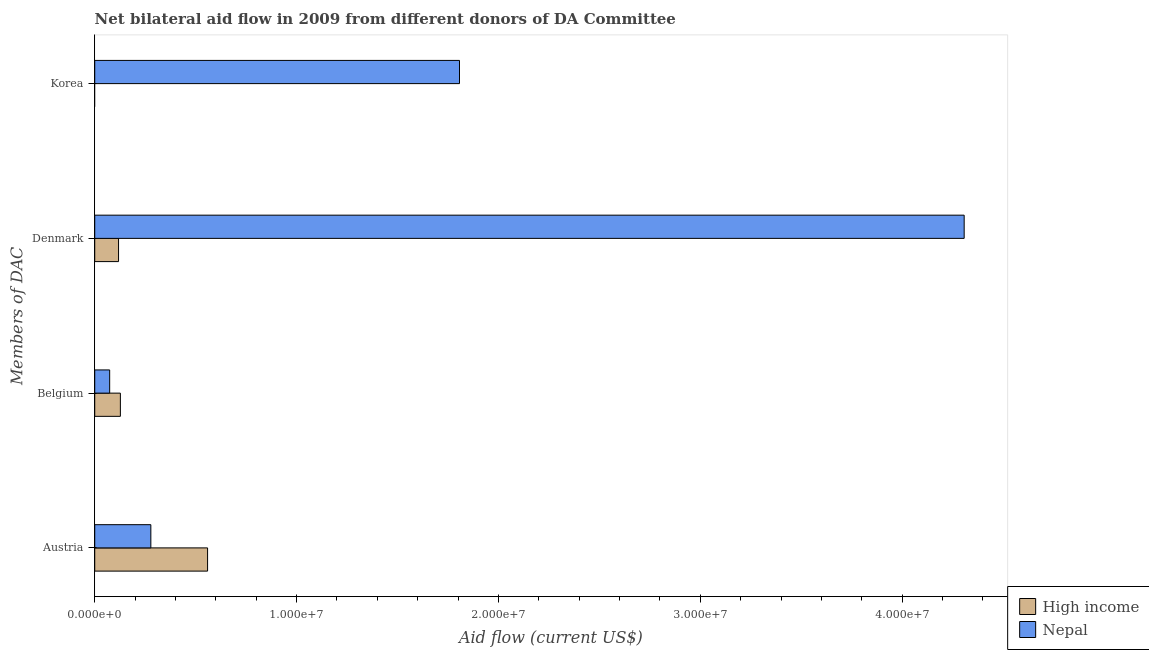Are the number of bars on each tick of the Y-axis equal?
Provide a succinct answer. No. How many bars are there on the 3rd tick from the top?
Make the answer very short. 2. How many bars are there on the 3rd tick from the bottom?
Provide a short and direct response. 2. What is the label of the 2nd group of bars from the top?
Ensure brevity in your answer.  Denmark. What is the amount of aid given by korea in Nepal?
Offer a very short reply. 1.81e+07. Across all countries, what is the maximum amount of aid given by denmark?
Offer a very short reply. 4.31e+07. Across all countries, what is the minimum amount of aid given by belgium?
Ensure brevity in your answer.  7.40e+05. In which country was the amount of aid given by austria maximum?
Your answer should be very brief. High income. What is the total amount of aid given by korea in the graph?
Provide a short and direct response. 1.81e+07. What is the difference between the amount of aid given by belgium in High income and that in Nepal?
Your answer should be very brief. 5.30e+05. What is the difference between the amount of aid given by belgium in Nepal and the amount of aid given by korea in High income?
Your answer should be compact. 7.40e+05. What is the average amount of aid given by denmark per country?
Provide a succinct answer. 2.21e+07. What is the difference between the amount of aid given by belgium and amount of aid given by korea in Nepal?
Offer a very short reply. -1.73e+07. What is the ratio of the amount of aid given by denmark in High income to that in Nepal?
Your answer should be very brief. 0.03. Is the amount of aid given by austria in High income less than that in Nepal?
Keep it short and to the point. No. What is the difference between the highest and the second highest amount of aid given by denmark?
Keep it short and to the point. 4.19e+07. What is the difference between the highest and the lowest amount of aid given by denmark?
Keep it short and to the point. 4.19e+07. In how many countries, is the amount of aid given by denmark greater than the average amount of aid given by denmark taken over all countries?
Offer a very short reply. 1. Is the sum of the amount of aid given by austria in Nepal and High income greater than the maximum amount of aid given by korea across all countries?
Your answer should be very brief. No. Is it the case that in every country, the sum of the amount of aid given by denmark and amount of aid given by austria is greater than the sum of amount of aid given by korea and amount of aid given by belgium?
Make the answer very short. No. How many countries are there in the graph?
Offer a terse response. 2. What is the difference between two consecutive major ticks on the X-axis?
Your answer should be compact. 1.00e+07. Does the graph contain any zero values?
Provide a succinct answer. Yes. Where does the legend appear in the graph?
Your response must be concise. Bottom right. How many legend labels are there?
Provide a short and direct response. 2. What is the title of the graph?
Make the answer very short. Net bilateral aid flow in 2009 from different donors of DA Committee. What is the label or title of the X-axis?
Offer a terse response. Aid flow (current US$). What is the label or title of the Y-axis?
Your answer should be very brief. Members of DAC. What is the Aid flow (current US$) of High income in Austria?
Provide a succinct answer. 5.59e+06. What is the Aid flow (current US$) in Nepal in Austria?
Make the answer very short. 2.78e+06. What is the Aid flow (current US$) of High income in Belgium?
Offer a very short reply. 1.27e+06. What is the Aid flow (current US$) of Nepal in Belgium?
Keep it short and to the point. 7.40e+05. What is the Aid flow (current US$) in High income in Denmark?
Make the answer very short. 1.18e+06. What is the Aid flow (current US$) in Nepal in Denmark?
Your answer should be very brief. 4.31e+07. What is the Aid flow (current US$) of High income in Korea?
Ensure brevity in your answer.  0. What is the Aid flow (current US$) in Nepal in Korea?
Ensure brevity in your answer.  1.81e+07. Across all Members of DAC, what is the maximum Aid flow (current US$) of High income?
Your answer should be compact. 5.59e+06. Across all Members of DAC, what is the maximum Aid flow (current US$) in Nepal?
Provide a succinct answer. 4.31e+07. Across all Members of DAC, what is the minimum Aid flow (current US$) of Nepal?
Ensure brevity in your answer.  7.40e+05. What is the total Aid flow (current US$) of High income in the graph?
Your answer should be very brief. 8.04e+06. What is the total Aid flow (current US$) of Nepal in the graph?
Give a very brief answer. 6.47e+07. What is the difference between the Aid flow (current US$) in High income in Austria and that in Belgium?
Offer a very short reply. 4.32e+06. What is the difference between the Aid flow (current US$) of Nepal in Austria and that in Belgium?
Offer a very short reply. 2.04e+06. What is the difference between the Aid flow (current US$) in High income in Austria and that in Denmark?
Provide a short and direct response. 4.41e+06. What is the difference between the Aid flow (current US$) of Nepal in Austria and that in Denmark?
Offer a very short reply. -4.03e+07. What is the difference between the Aid flow (current US$) in Nepal in Austria and that in Korea?
Keep it short and to the point. -1.53e+07. What is the difference between the Aid flow (current US$) in High income in Belgium and that in Denmark?
Your answer should be compact. 9.00e+04. What is the difference between the Aid flow (current US$) of Nepal in Belgium and that in Denmark?
Give a very brief answer. -4.23e+07. What is the difference between the Aid flow (current US$) of Nepal in Belgium and that in Korea?
Offer a terse response. -1.73e+07. What is the difference between the Aid flow (current US$) of Nepal in Denmark and that in Korea?
Make the answer very short. 2.50e+07. What is the difference between the Aid flow (current US$) in High income in Austria and the Aid flow (current US$) in Nepal in Belgium?
Provide a succinct answer. 4.85e+06. What is the difference between the Aid flow (current US$) of High income in Austria and the Aid flow (current US$) of Nepal in Denmark?
Your answer should be very brief. -3.75e+07. What is the difference between the Aid flow (current US$) of High income in Austria and the Aid flow (current US$) of Nepal in Korea?
Ensure brevity in your answer.  -1.25e+07. What is the difference between the Aid flow (current US$) in High income in Belgium and the Aid flow (current US$) in Nepal in Denmark?
Your answer should be very brief. -4.18e+07. What is the difference between the Aid flow (current US$) of High income in Belgium and the Aid flow (current US$) of Nepal in Korea?
Ensure brevity in your answer.  -1.68e+07. What is the difference between the Aid flow (current US$) of High income in Denmark and the Aid flow (current US$) of Nepal in Korea?
Your answer should be compact. -1.69e+07. What is the average Aid flow (current US$) of High income per Members of DAC?
Offer a terse response. 2.01e+06. What is the average Aid flow (current US$) in Nepal per Members of DAC?
Give a very brief answer. 1.62e+07. What is the difference between the Aid flow (current US$) in High income and Aid flow (current US$) in Nepal in Austria?
Your answer should be very brief. 2.81e+06. What is the difference between the Aid flow (current US$) of High income and Aid flow (current US$) of Nepal in Belgium?
Provide a short and direct response. 5.30e+05. What is the difference between the Aid flow (current US$) of High income and Aid flow (current US$) of Nepal in Denmark?
Offer a very short reply. -4.19e+07. What is the ratio of the Aid flow (current US$) of High income in Austria to that in Belgium?
Give a very brief answer. 4.4. What is the ratio of the Aid flow (current US$) in Nepal in Austria to that in Belgium?
Offer a very short reply. 3.76. What is the ratio of the Aid flow (current US$) in High income in Austria to that in Denmark?
Your answer should be very brief. 4.74. What is the ratio of the Aid flow (current US$) of Nepal in Austria to that in Denmark?
Ensure brevity in your answer.  0.06. What is the ratio of the Aid flow (current US$) of Nepal in Austria to that in Korea?
Your answer should be very brief. 0.15. What is the ratio of the Aid flow (current US$) in High income in Belgium to that in Denmark?
Provide a succinct answer. 1.08. What is the ratio of the Aid flow (current US$) in Nepal in Belgium to that in Denmark?
Your answer should be compact. 0.02. What is the ratio of the Aid flow (current US$) of Nepal in Belgium to that in Korea?
Offer a terse response. 0.04. What is the ratio of the Aid flow (current US$) in Nepal in Denmark to that in Korea?
Provide a short and direct response. 2.38. What is the difference between the highest and the second highest Aid flow (current US$) of High income?
Your answer should be compact. 4.32e+06. What is the difference between the highest and the second highest Aid flow (current US$) in Nepal?
Provide a succinct answer. 2.50e+07. What is the difference between the highest and the lowest Aid flow (current US$) of High income?
Your answer should be very brief. 5.59e+06. What is the difference between the highest and the lowest Aid flow (current US$) of Nepal?
Ensure brevity in your answer.  4.23e+07. 